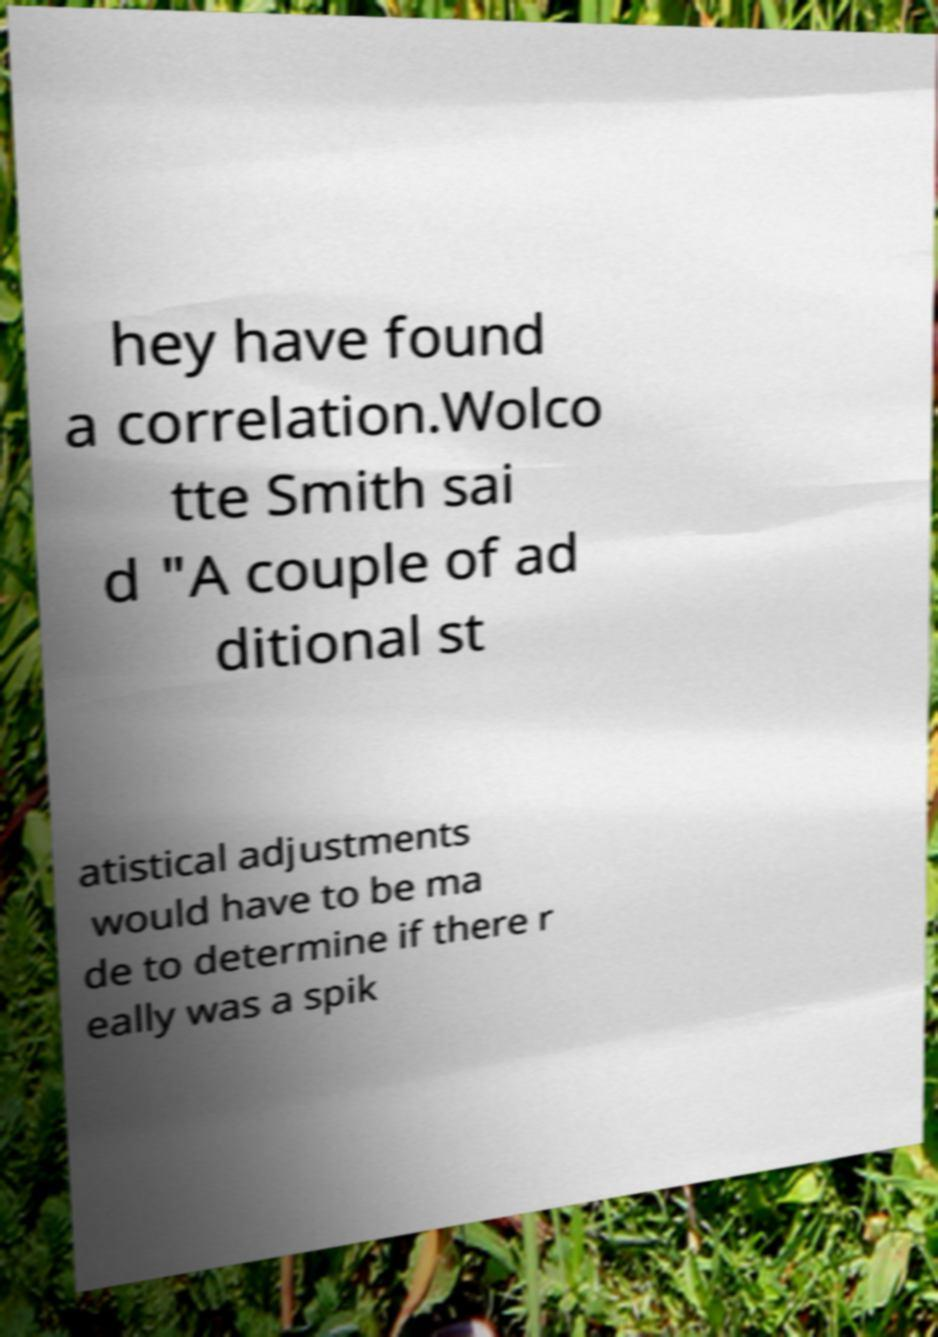Please read and relay the text visible in this image. What does it say? hey have found a correlation.Wolco tte Smith sai d "A couple of ad ditional st atistical adjustments would have to be ma de to determine if there r eally was a spik 